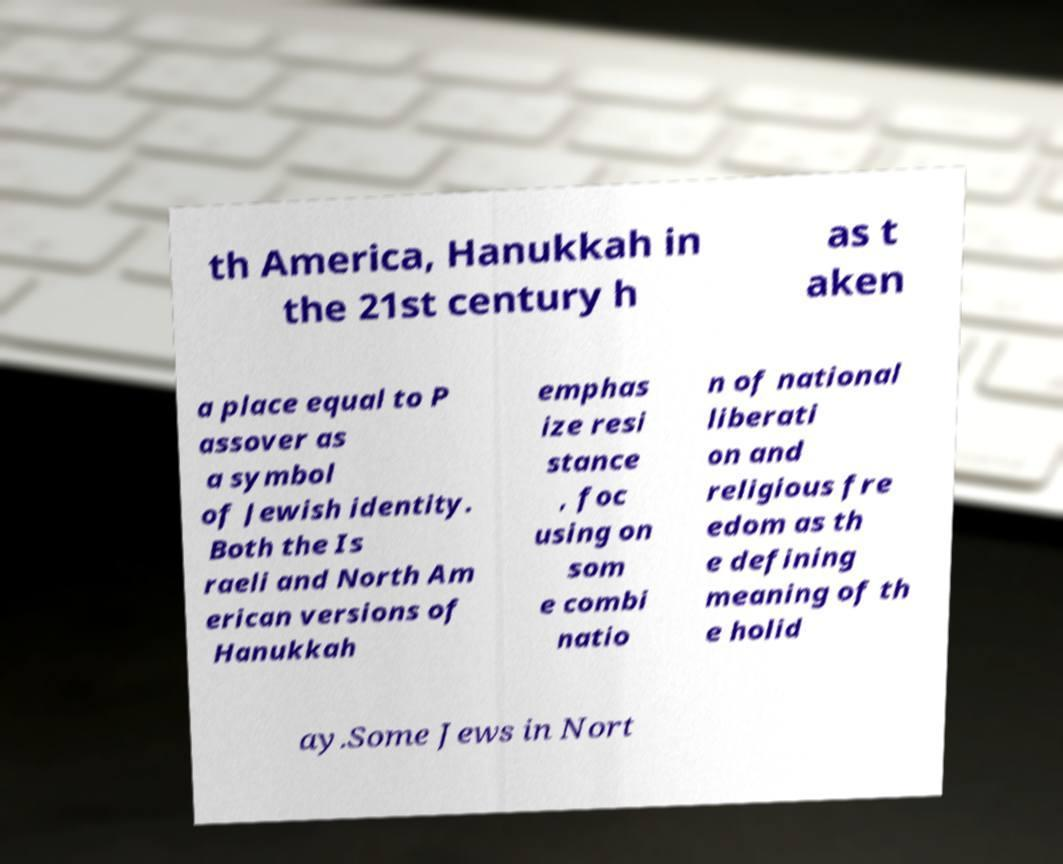For documentation purposes, I need the text within this image transcribed. Could you provide that? th America, Hanukkah in the 21st century h as t aken a place equal to P assover as a symbol of Jewish identity. Both the Is raeli and North Am erican versions of Hanukkah emphas ize resi stance , foc using on som e combi natio n of national liberati on and religious fre edom as th e defining meaning of th e holid ay.Some Jews in Nort 